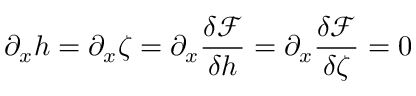Convert formula to latex. <formula><loc_0><loc_0><loc_500><loc_500>\partial _ { x } h = \partial _ { x } \zeta = \partial _ { x } \frac { \delta \mathcal { F } } { \delta h } = \partial _ { x } \frac { \delta \mathcal { F } } { \delta \zeta } = 0</formula> 